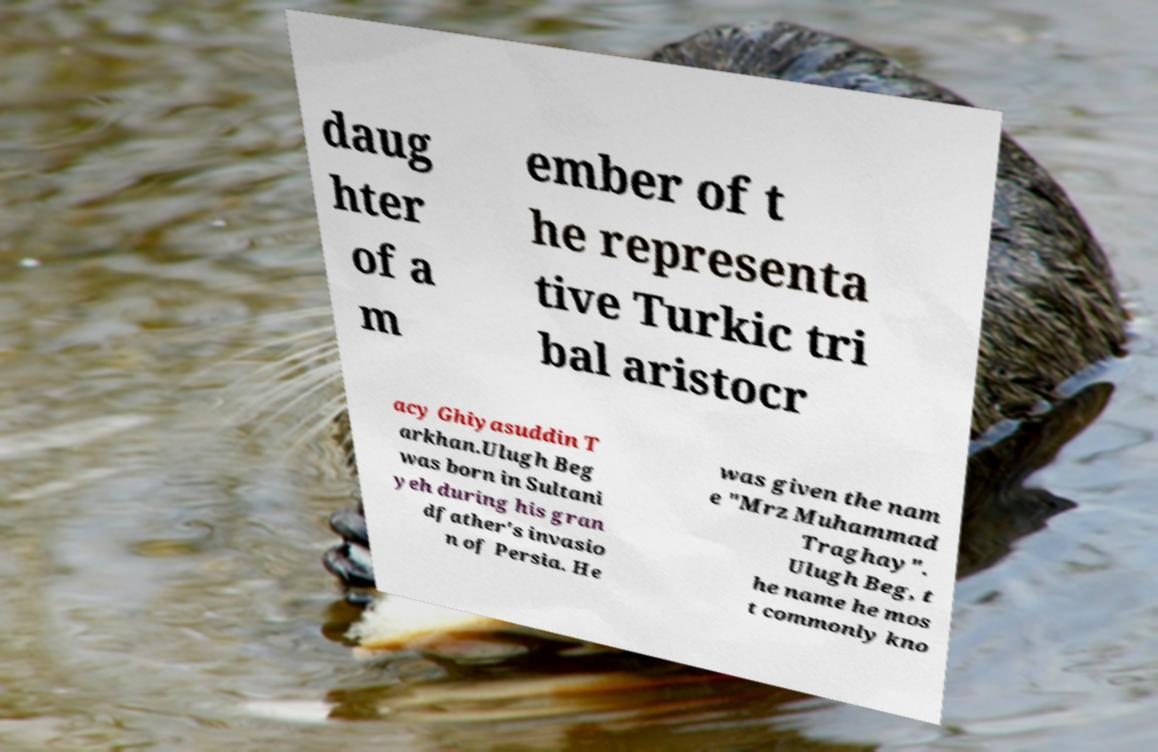What messages or text are displayed in this image? I need them in a readable, typed format. daug hter of a m ember of t he representa tive Turkic tri bal aristocr acy Ghiyasuddin T arkhan.Ulugh Beg was born in Sultani yeh during his gran dfather's invasio n of Persia. He was given the nam e "Mrz Muhammad Traghay". Ulugh Beg, t he name he mos t commonly kno 